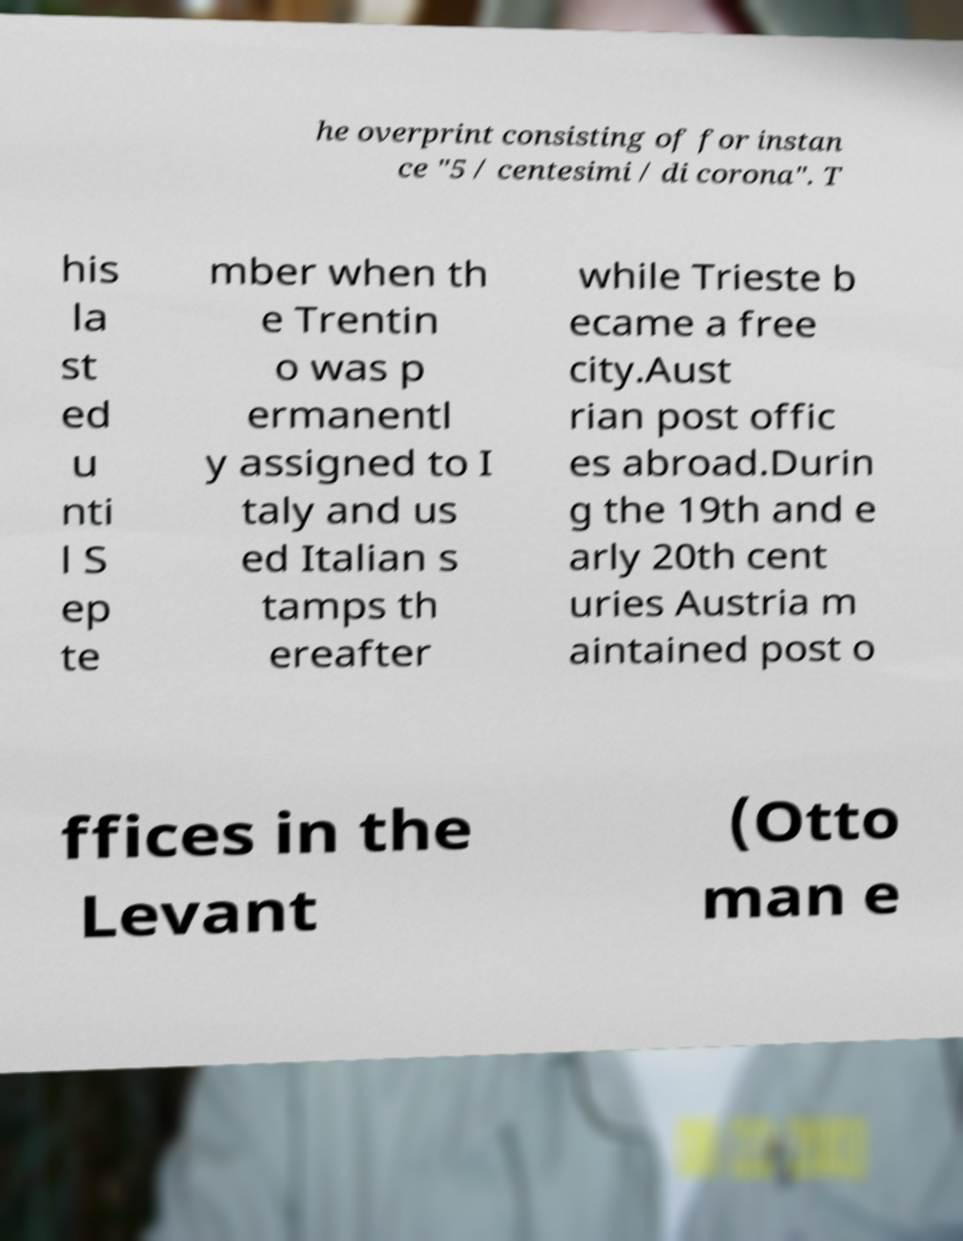Can you read and provide the text displayed in the image?This photo seems to have some interesting text. Can you extract and type it out for me? he overprint consisting of for instan ce "5 / centesimi / di corona". T his la st ed u nti l S ep te mber when th e Trentin o was p ermanentl y assigned to I taly and us ed Italian s tamps th ereafter while Trieste b ecame a free city.Aust rian post offic es abroad.Durin g the 19th and e arly 20th cent uries Austria m aintained post o ffices in the Levant (Otto man e 